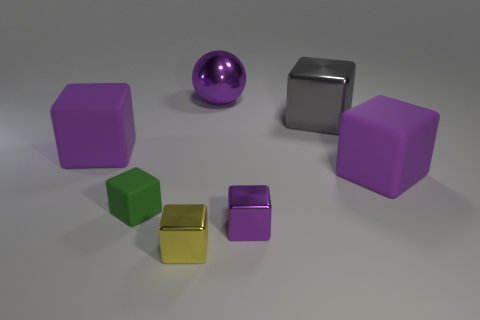The large object that is made of the same material as the gray cube is what color?
Ensure brevity in your answer.  Purple. Do the rubber object right of the large purple metal sphere and the tiny thing on the left side of the yellow metallic cube have the same color?
Provide a succinct answer. No. What number of cylinders are either large gray matte objects or green matte objects?
Your answer should be compact. 0. Are there an equal number of small purple objects right of the big gray metal cube and large matte cubes?
Provide a succinct answer. No. What is the large purple block that is behind the large purple cube on the right side of the small cube to the left of the small yellow object made of?
Offer a very short reply. Rubber. What material is the tiny thing that is the same color as the shiny sphere?
Provide a short and direct response. Metal. What number of things are either cubes in front of the green object or yellow metallic objects?
Make the answer very short. 2. How many things are big brown shiny cylinders or big rubber objects on the left side of the tiny green matte block?
Your answer should be compact. 1. There is a large metal thing to the left of the tiny metallic object that is right of the purple metal sphere; how many purple balls are in front of it?
Your answer should be compact. 0. What material is the purple object that is the same size as the green matte thing?
Your answer should be compact. Metal. 